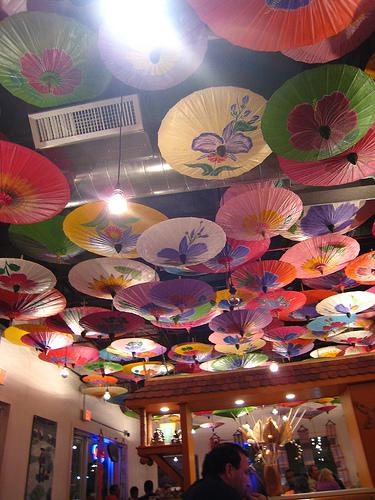Question: what is the ceiling covered with?
Choices:
A. Tiles.
B. Paper airplanes.
C. Paper flowers.
D. Paper umbrellas.
Answer with the letter. Answer: D Question: where was this picture taken?
Choices:
A. Hotel.
B. Restaurant.
C. Coffee shop.
D. Farm house.
Answer with the letter. Answer: B Question: what item is on all the paper umbrellas?
Choices:
A. Cupid.
B. Butterfly.
C. Fireworks.
D. Flower.
Answer with the letter. Answer: D 